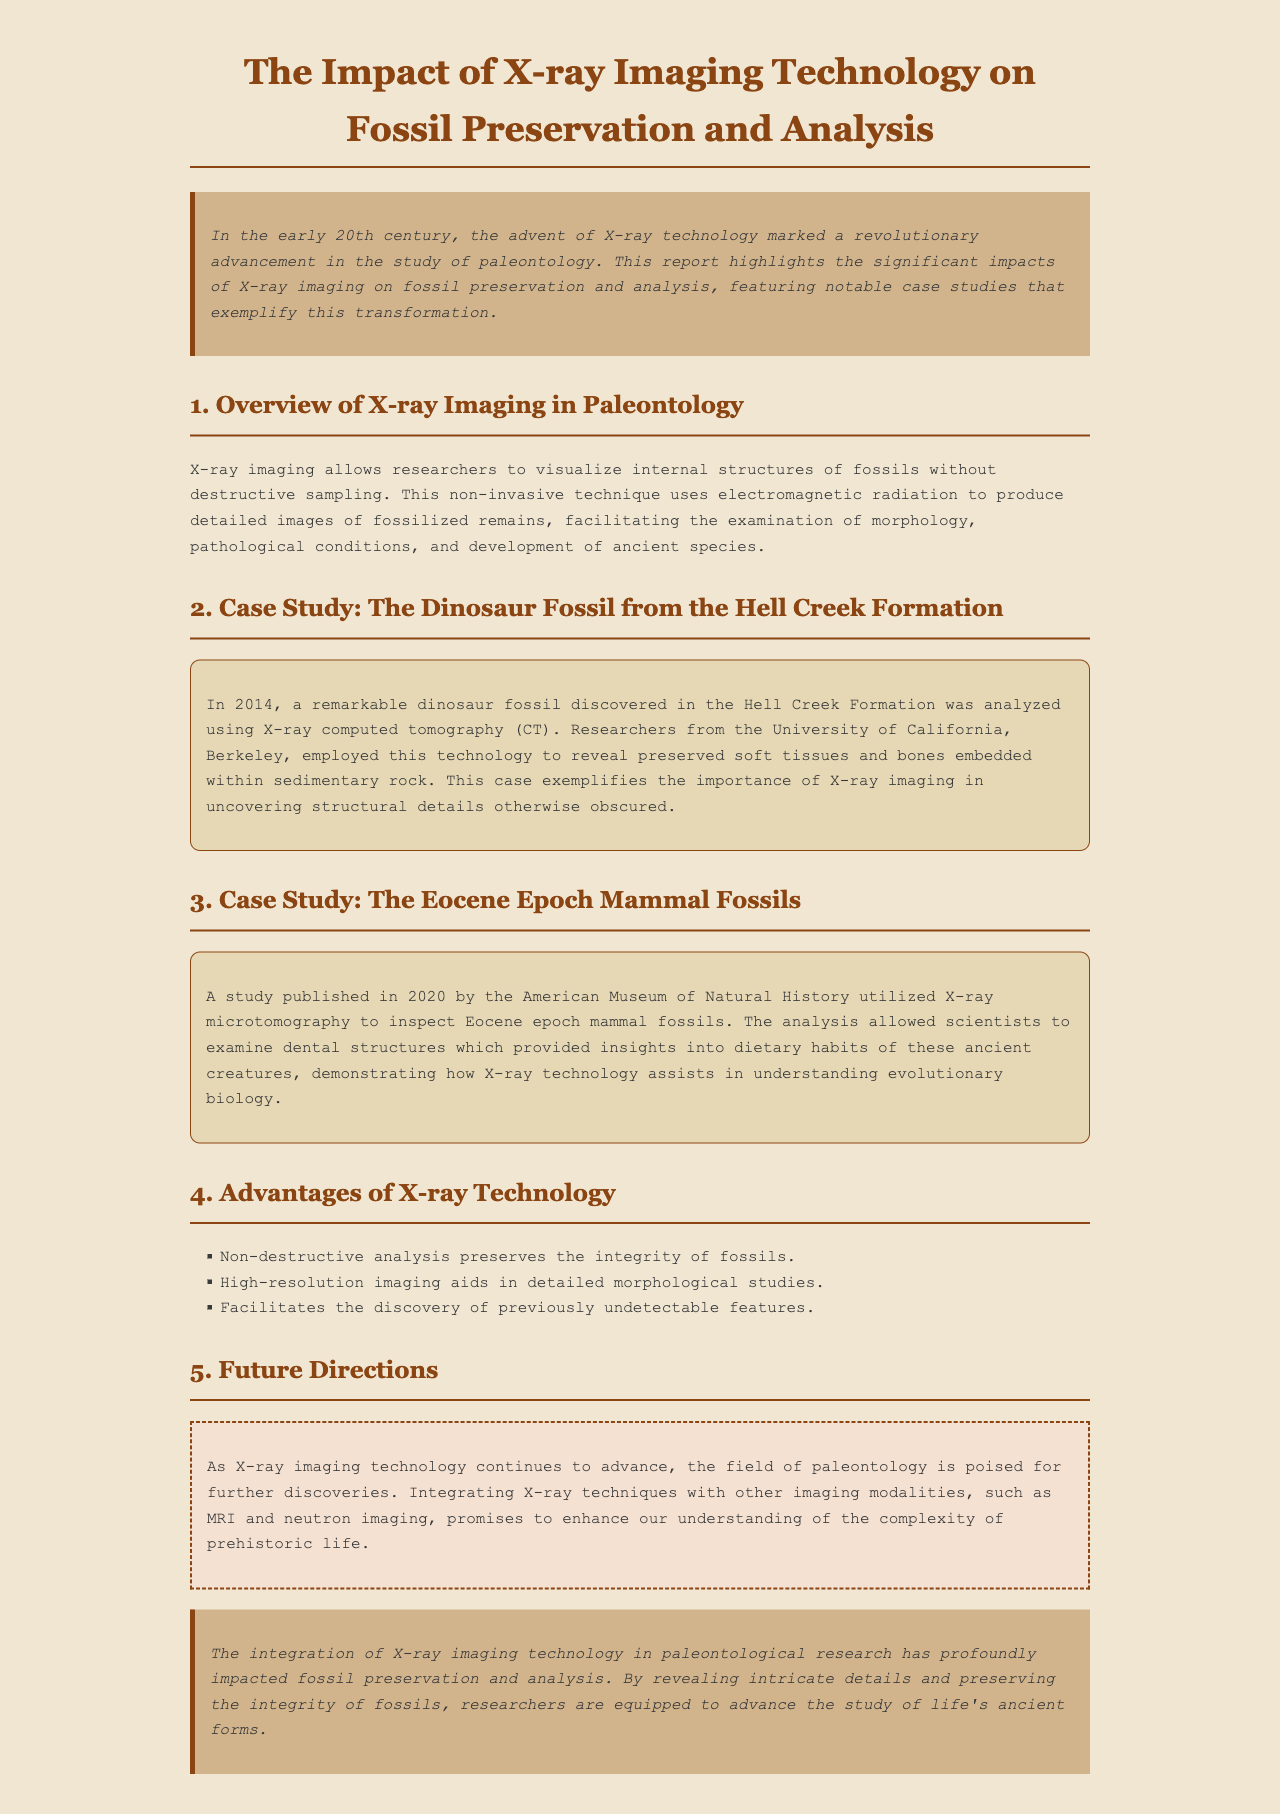What year was the dinosaur fossil from the Hell Creek Formation analyzed? The report states that the dinosaur fossil was analyzed in 2014.
Answer: 2014 Which university conducted the analysis of the dinosaur fossil? The analysis of the dinosaur fossil was conducted by researchers from the University of California, Berkeley.
Answer: University of California, Berkeley What technique was used to analyze the Eocene epoch mammal fossils? The report mentions X-ray microtomography as the technique used to analyze the Eocene epoch mammal fossils.
Answer: X-ray microtomography How many case studies are featured in the report? There are two case studies highlighted in the report.
Answer: Two What is one advantage of X-ray technology mentioned in the document? The document lists non-destructive analysis as an advantage of X-ray technology.
Answer: Non-destructive analysis What is a future direction mentioned for X-ray imaging technology in paleontology? The report states that integrating X-ray techniques with other imaging modalities promises further discoveries.
Answer: Integrating X-ray techniques with other imaging modalities What is the focus of the introduction in the report? The introduction highlights the significant impacts of X-ray imaging on fossil preservation and analysis.
Answer: Significant impacts of X-ray imaging on fossil preservation and analysis What type of report is this document classified as? The document is classified as an impact report.
Answer: Impact report 